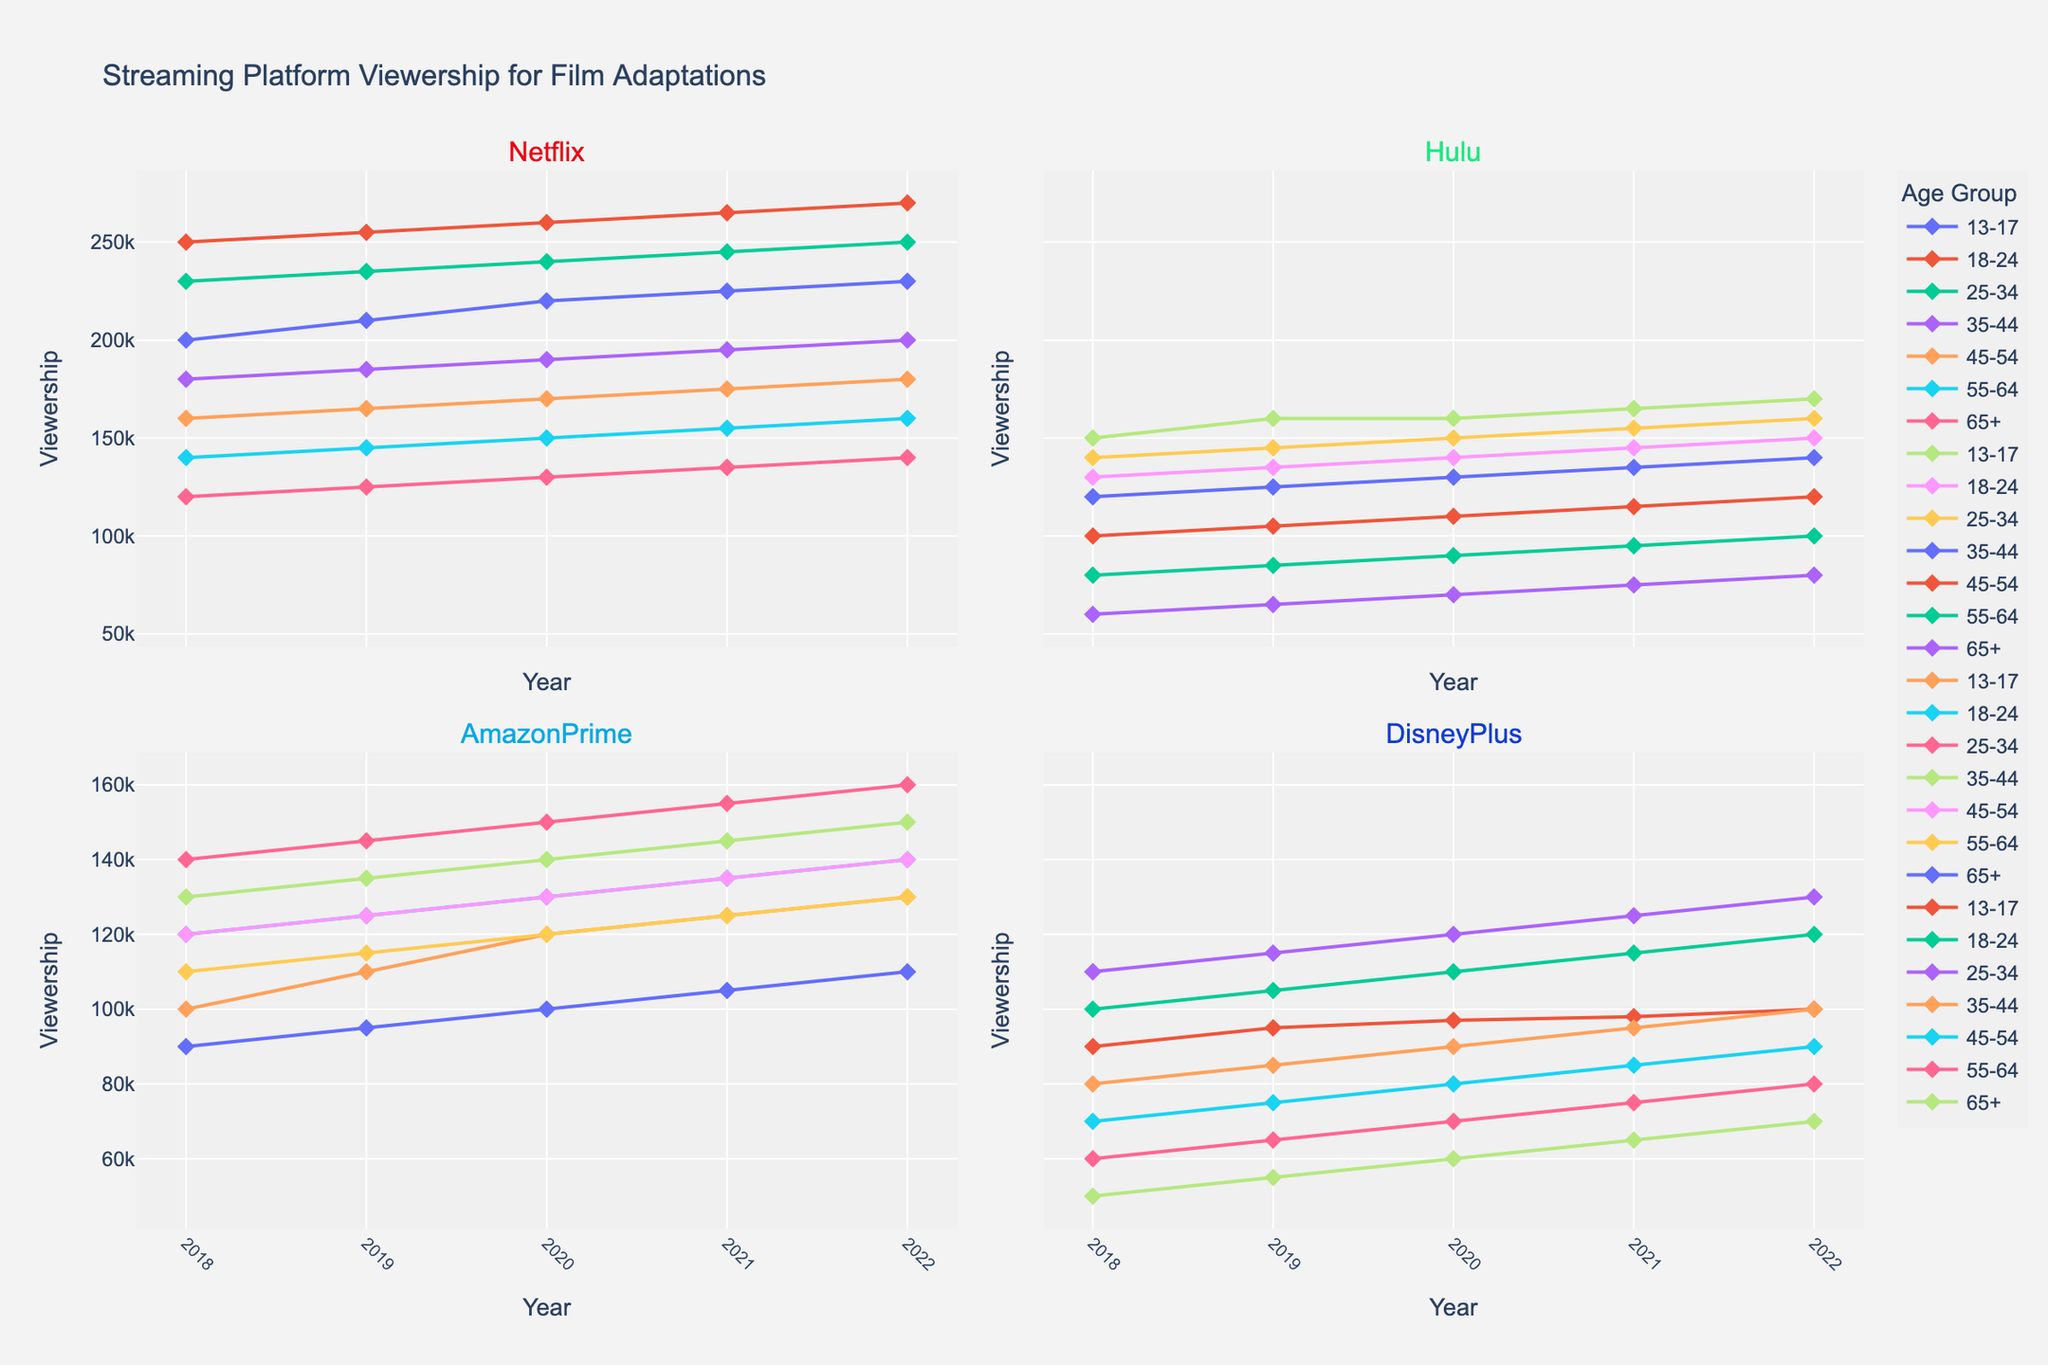What is the title of the plot? Look at the top of the figure where the title is displayed. The title summarizes what the figure represents.
Answer: "Streaming Platform Viewership for Film Adaptations" Which age group has the highest viewership on Netflix in 2022? Look at the subplot for Netflix and find the point for the year 2022. Identify which age group's line reaches the highest value.
Answer: 18-24 How does the viewership of Amazon Prime for the age group 25-34 change from 2018 to 2022? Look at the subplot for Amazon Prime and follow the line for the age group 25-34 from 2018 to 2022. Note the trend in the y-values over the years.
Answer: It increases from 140000 to 160000 Which platform had the least viewership from the 65+ age group in 2018? Look at the 2018 data points for the 65+ age group across all four subplots (platforms). Identify the one with the lowest y-value.
Answer: Disney Plus What is the total viewership for Hulu for all age groups in 2019? For the Hulu subplot, identify the y-value for each age group in 2019 and sum them up. Values are 160000, 135000, 145000, 125000, 105000, 85000, and 65000. So, the sum is 160000 + 135000 + 145000 + 125000 + 105000 + 85000 + 65000 = 820000.
Answer: 820000 Which age group shows a consistent increase in viewership on Disney Plus from 2018 to 2022? Look at the Disney Plus subplot and examine the trend for each age group's line. Identify which one shows a consistent rise over the years.
Answer: 18-24 Compare the viewership trends of Netflix for the age groups 13-17 and 35-44 from 2018 to 2022. Which group shows a higher overall increase? Look at the Netflix subplot lines for both age groups from 2018 to 2022. Identify the starting and ending points for each group and calculate the increase. For 13-17, it's from 200000 to 230000 (increase of 30000); for 35-44, it's from 180000 to 200000 (increase of 20000). The age group 13-17 shows a higher increase.
Answer: 13-17 What is the average viewership for Amazon Prime across all age groups in 2020? For the Amazon Prime subplot, find the viewership values for all age groups in 2020: 120000, 130000, 150000, 140000, 130000, 120000, and 100000. Sum them up (120000 + 130000 + 150000 + 140000 + 130000 + 120000 + 100000 = 890000) and divide by the number of age groups (7).
Answer: 127142.9 Which platform shows the most significant drop in viewership for the age group of 45-54 from 2018 to 2022? Examine the lines for the age group 45-54 in each subplot, observe the starting and ending y-values. Calculate the difference for each platform. Netflix shows little change (160000 to 180000), Hulu shows an increase (100000 to 120000), Amazon Prime (120000 to 140000), and Disney Plus shows an increase (70000 to 90000).
Answer: None, there are no significant drops 